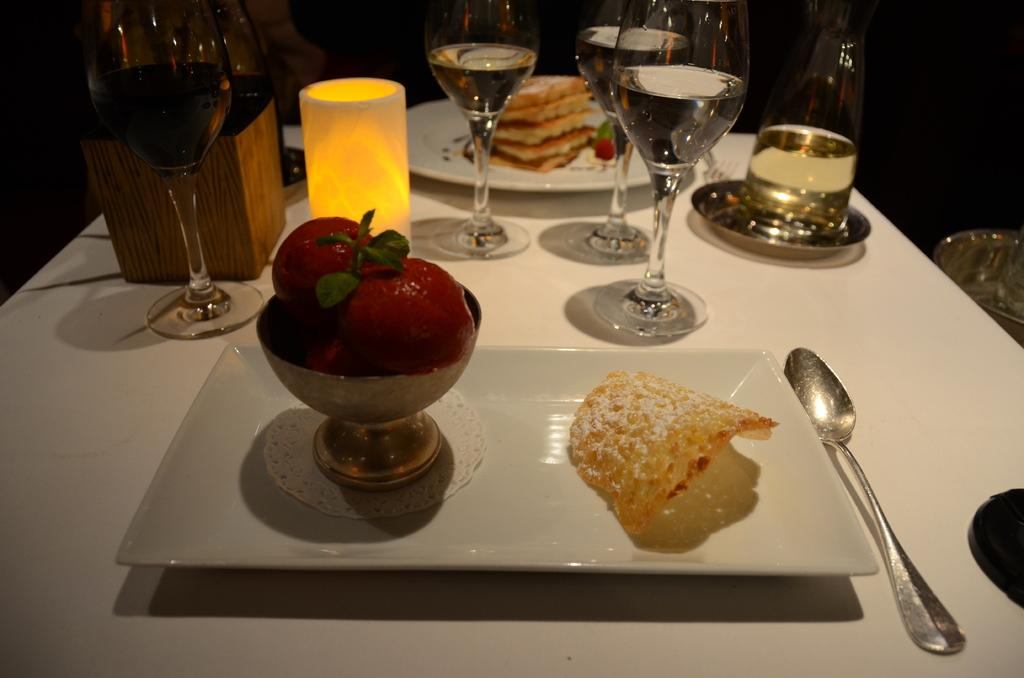What type of items can be seen on the table in the image? There are eatables and drinks on the table. Can you describe the eatables in more detail? Unfortunately, the specific type of eatables cannot be determined from the provided facts. What kind of drinks are present on the table? The specific type of drinks cannot be determined from the provided facts. What color is the sock that is hanging on the iron in the image? There is no sock or iron present in the image. 